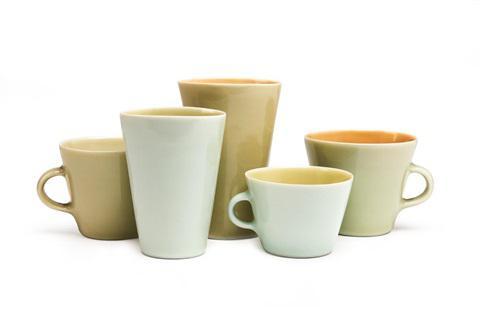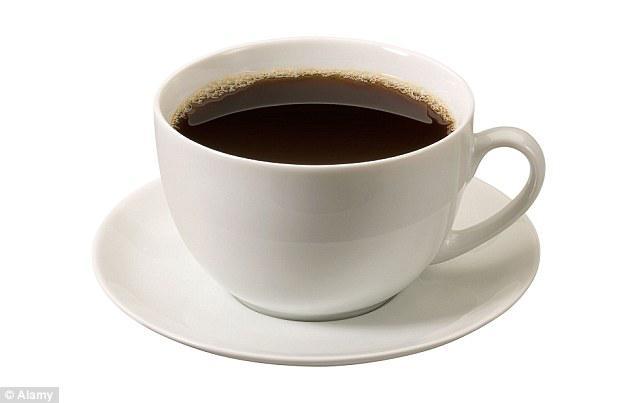The first image is the image on the left, the second image is the image on the right. Analyze the images presented: Is the assertion "There are three cups and three saucers in one of the images." valid? Answer yes or no. No. The first image is the image on the left, the second image is the image on the right. Evaluate the accuracy of this statement regarding the images: "An image shows a neat row of three matching cups and saucers.". Is it true? Answer yes or no. No. 